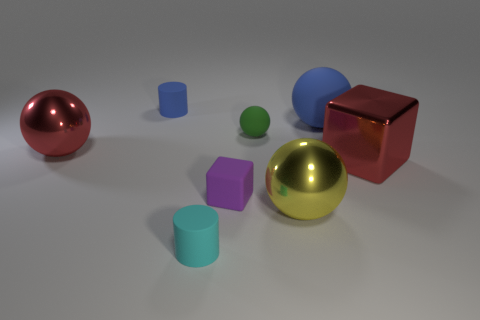Subtract all tiny matte spheres. How many spheres are left? 3 Subtract all green balls. How many balls are left? 3 Add 2 green rubber objects. How many objects exist? 10 Subtract all purple balls. Subtract all purple cylinders. How many balls are left? 4 Subtract all blocks. How many objects are left? 6 Subtract all tiny yellow rubber things. Subtract all purple cubes. How many objects are left? 7 Add 3 tiny rubber balls. How many tiny rubber balls are left? 4 Add 3 big metallic balls. How many big metallic balls exist? 5 Subtract 1 purple cubes. How many objects are left? 7 